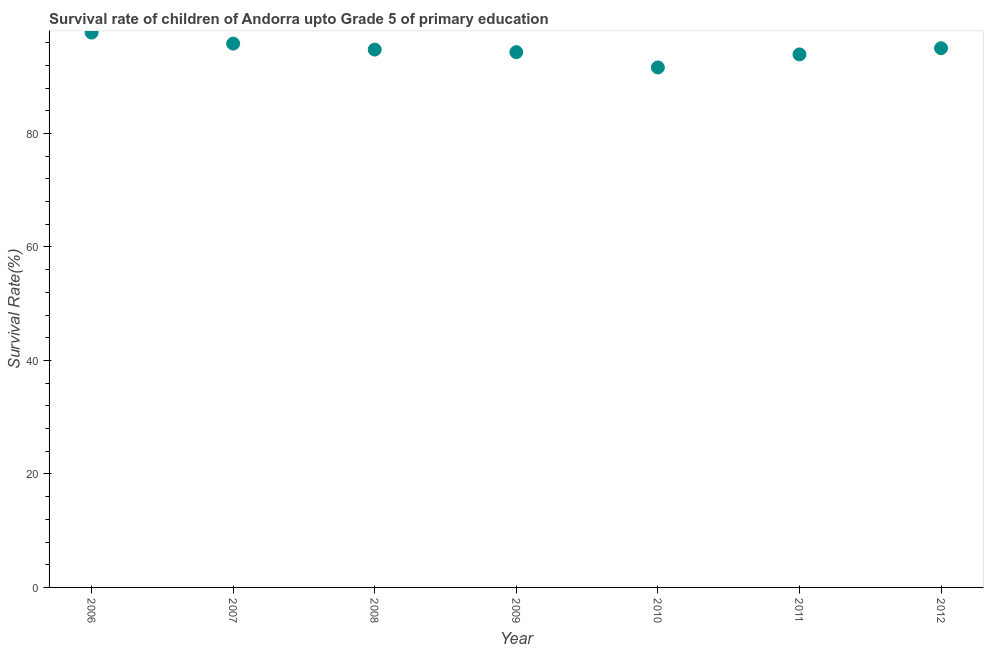What is the survival rate in 2008?
Provide a short and direct response. 94.78. Across all years, what is the maximum survival rate?
Keep it short and to the point. 97.78. Across all years, what is the minimum survival rate?
Offer a very short reply. 91.64. What is the sum of the survival rate?
Your response must be concise. 663.33. What is the difference between the survival rate in 2007 and 2010?
Make the answer very short. 4.2. What is the average survival rate per year?
Offer a terse response. 94.76. What is the median survival rate?
Offer a very short reply. 94.78. What is the ratio of the survival rate in 2006 to that in 2009?
Ensure brevity in your answer.  1.04. What is the difference between the highest and the second highest survival rate?
Provide a short and direct response. 1.95. Is the sum of the survival rate in 2006 and 2007 greater than the maximum survival rate across all years?
Your response must be concise. Yes. What is the difference between the highest and the lowest survival rate?
Your answer should be very brief. 6.15. How many dotlines are there?
Provide a succinct answer. 1. What is the difference between two consecutive major ticks on the Y-axis?
Offer a terse response. 20. Does the graph contain any zero values?
Make the answer very short. No. What is the title of the graph?
Your response must be concise. Survival rate of children of Andorra upto Grade 5 of primary education. What is the label or title of the Y-axis?
Offer a terse response. Survival Rate(%). What is the Survival Rate(%) in 2006?
Your response must be concise. 97.78. What is the Survival Rate(%) in 2007?
Your answer should be very brief. 95.84. What is the Survival Rate(%) in 2008?
Your answer should be very brief. 94.78. What is the Survival Rate(%) in 2009?
Provide a short and direct response. 94.33. What is the Survival Rate(%) in 2010?
Your response must be concise. 91.64. What is the Survival Rate(%) in 2011?
Keep it short and to the point. 93.93. What is the Survival Rate(%) in 2012?
Give a very brief answer. 95.02. What is the difference between the Survival Rate(%) in 2006 and 2007?
Give a very brief answer. 1.95. What is the difference between the Survival Rate(%) in 2006 and 2008?
Ensure brevity in your answer.  3. What is the difference between the Survival Rate(%) in 2006 and 2009?
Make the answer very short. 3.45. What is the difference between the Survival Rate(%) in 2006 and 2010?
Your response must be concise. 6.15. What is the difference between the Survival Rate(%) in 2006 and 2011?
Your response must be concise. 3.85. What is the difference between the Survival Rate(%) in 2006 and 2012?
Give a very brief answer. 2.76. What is the difference between the Survival Rate(%) in 2007 and 2008?
Your answer should be very brief. 1.05. What is the difference between the Survival Rate(%) in 2007 and 2009?
Provide a short and direct response. 1.51. What is the difference between the Survival Rate(%) in 2007 and 2010?
Your answer should be compact. 4.2. What is the difference between the Survival Rate(%) in 2007 and 2011?
Offer a very short reply. 1.9. What is the difference between the Survival Rate(%) in 2007 and 2012?
Offer a very short reply. 0.81. What is the difference between the Survival Rate(%) in 2008 and 2009?
Offer a terse response. 0.45. What is the difference between the Survival Rate(%) in 2008 and 2010?
Offer a very short reply. 3.15. What is the difference between the Survival Rate(%) in 2008 and 2011?
Your answer should be compact. 0.85. What is the difference between the Survival Rate(%) in 2008 and 2012?
Your answer should be compact. -0.24. What is the difference between the Survival Rate(%) in 2009 and 2010?
Make the answer very short. 2.69. What is the difference between the Survival Rate(%) in 2009 and 2011?
Keep it short and to the point. 0.4. What is the difference between the Survival Rate(%) in 2009 and 2012?
Provide a succinct answer. -0.7. What is the difference between the Survival Rate(%) in 2010 and 2011?
Give a very brief answer. -2.3. What is the difference between the Survival Rate(%) in 2010 and 2012?
Provide a succinct answer. -3.39. What is the difference between the Survival Rate(%) in 2011 and 2012?
Keep it short and to the point. -1.09. What is the ratio of the Survival Rate(%) in 2006 to that in 2007?
Your response must be concise. 1.02. What is the ratio of the Survival Rate(%) in 2006 to that in 2008?
Provide a succinct answer. 1.03. What is the ratio of the Survival Rate(%) in 2006 to that in 2010?
Ensure brevity in your answer.  1.07. What is the ratio of the Survival Rate(%) in 2006 to that in 2011?
Keep it short and to the point. 1.04. What is the ratio of the Survival Rate(%) in 2007 to that in 2010?
Make the answer very short. 1.05. What is the ratio of the Survival Rate(%) in 2008 to that in 2009?
Keep it short and to the point. 1. What is the ratio of the Survival Rate(%) in 2008 to that in 2010?
Ensure brevity in your answer.  1.03. What is the ratio of the Survival Rate(%) in 2008 to that in 2012?
Provide a succinct answer. 1. What is the ratio of the Survival Rate(%) in 2010 to that in 2011?
Offer a very short reply. 0.98. What is the ratio of the Survival Rate(%) in 2010 to that in 2012?
Keep it short and to the point. 0.96. What is the ratio of the Survival Rate(%) in 2011 to that in 2012?
Make the answer very short. 0.99. 